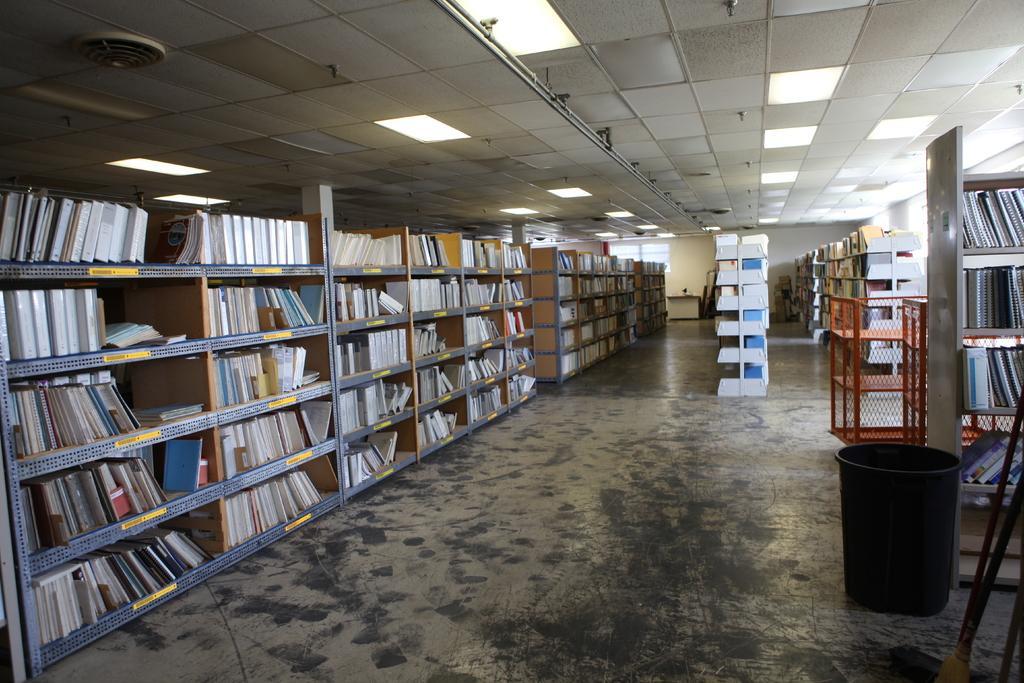Can you describe this image briefly? This image is taken in a library which contains many racks, books, a basket and a table. 